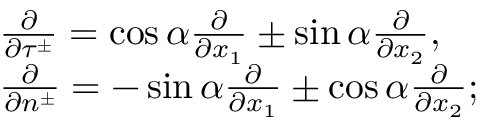<formula> <loc_0><loc_0><loc_500><loc_500>\begin{array} { r l } & { \frac { \partial } { \partial \tau ^ { \pm } } = \cos \alpha \frac { \partial } { \partial x _ { 1 } } \pm \sin \alpha \frac { \partial } { \partial x _ { 2 } } , } \\ & { \frac { \partial } { \partial n ^ { \pm } } = - \sin \alpha \frac { \partial } { \partial x _ { 1 } } \pm \cos \alpha \frac { \partial } { \partial x _ { 2 } } ; } \end{array}</formula> 